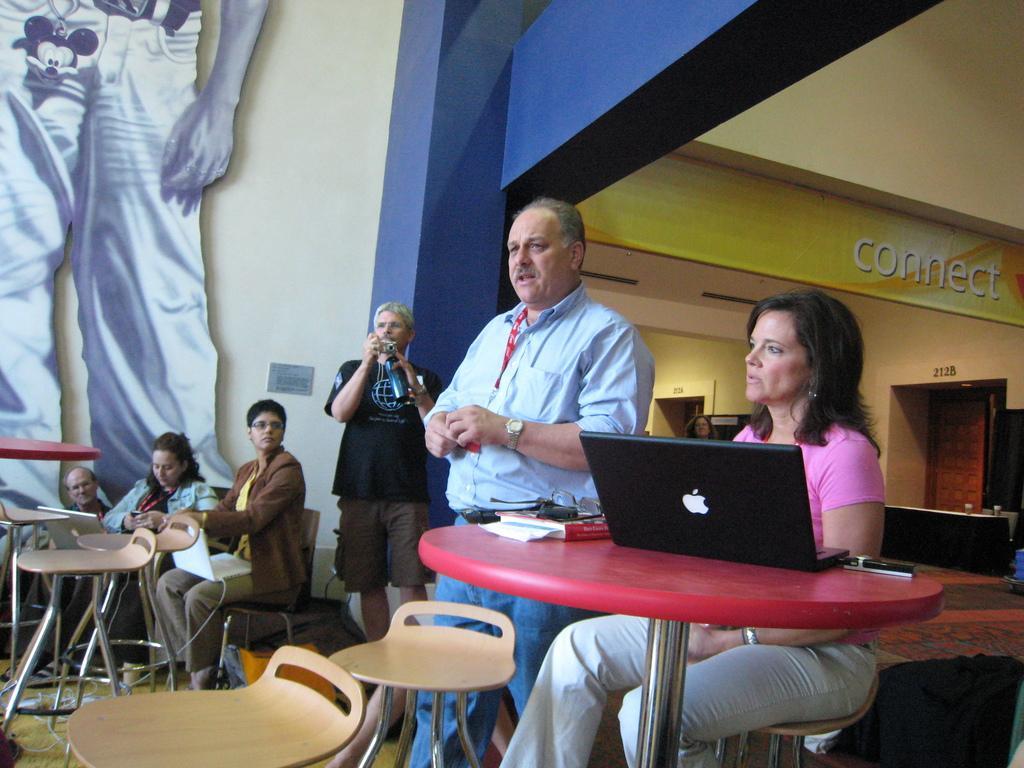Can you describe this image briefly? This image is clicked in a restaurant. In the front, there is a woman sitting and wearing a pink t-shirt is sitting in a chair. In front of her, there is a table in red color on which a laptop is kept. Beside her there is a man standing and wearing blue shirt. To the left, there is a poster on the wall. There are many chairs in this image. 